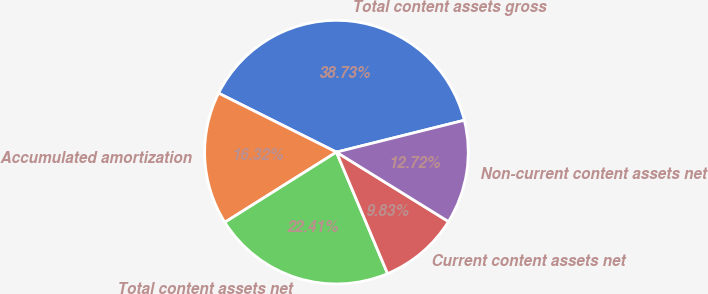Convert chart. <chart><loc_0><loc_0><loc_500><loc_500><pie_chart><fcel>Total content assets gross<fcel>Accumulated amortization<fcel>Total content assets net<fcel>Current content assets net<fcel>Non-current content assets net<nl><fcel>38.73%<fcel>16.32%<fcel>22.41%<fcel>9.83%<fcel>12.72%<nl></chart> 